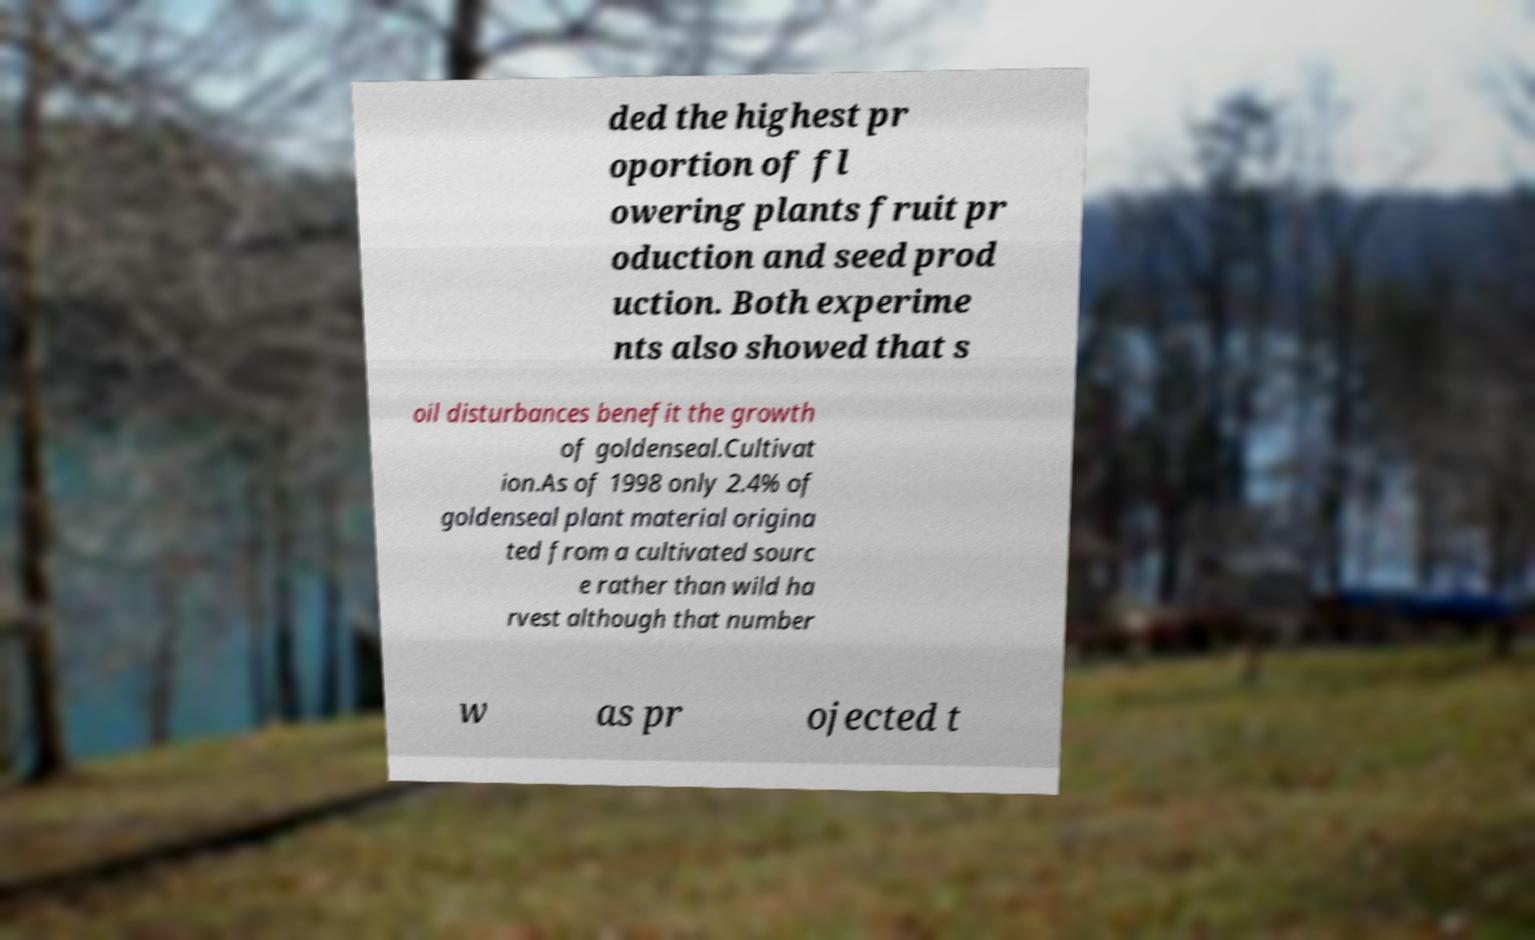Can you accurately transcribe the text from the provided image for me? ded the highest pr oportion of fl owering plants fruit pr oduction and seed prod uction. Both experime nts also showed that s oil disturbances benefit the growth of goldenseal.Cultivat ion.As of 1998 only 2.4% of goldenseal plant material origina ted from a cultivated sourc e rather than wild ha rvest although that number w as pr ojected t 